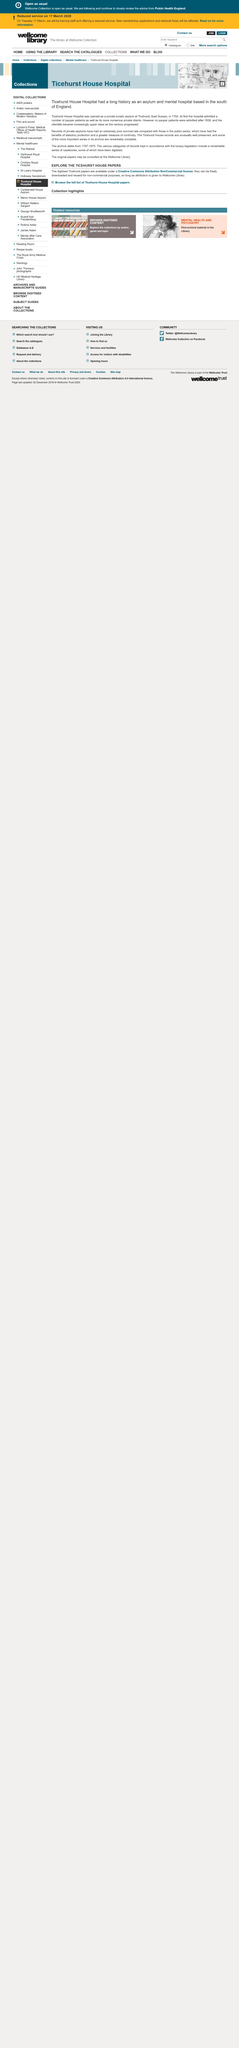Point out several critical features in this image. In 1792, Ticehurst House Hospital was opened. The article states that the Ticehurst House records are unusually well preserved, with many important series being complete. Ticehurst House Hospital, which had a long history as an asylum located in the south of England, is now a private mental health treatment center. 